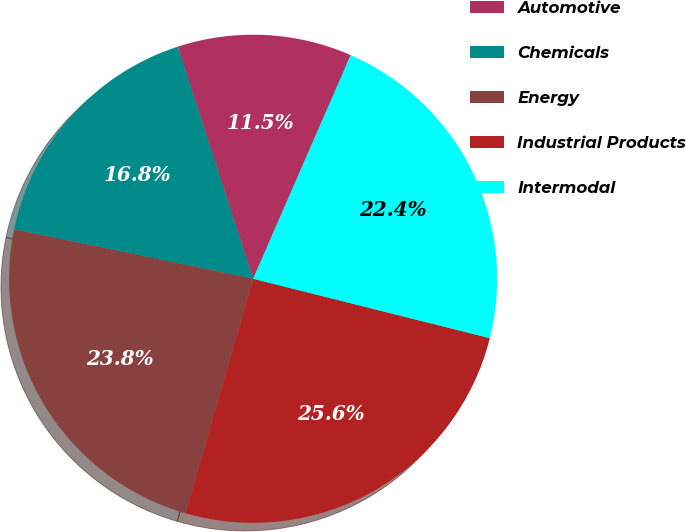Convert chart. <chart><loc_0><loc_0><loc_500><loc_500><pie_chart><fcel>Automotive<fcel>Chemicals<fcel>Energy<fcel>Industrial Products<fcel>Intermodal<nl><fcel>11.54%<fcel>16.75%<fcel>23.78%<fcel>25.56%<fcel>22.37%<nl></chart> 